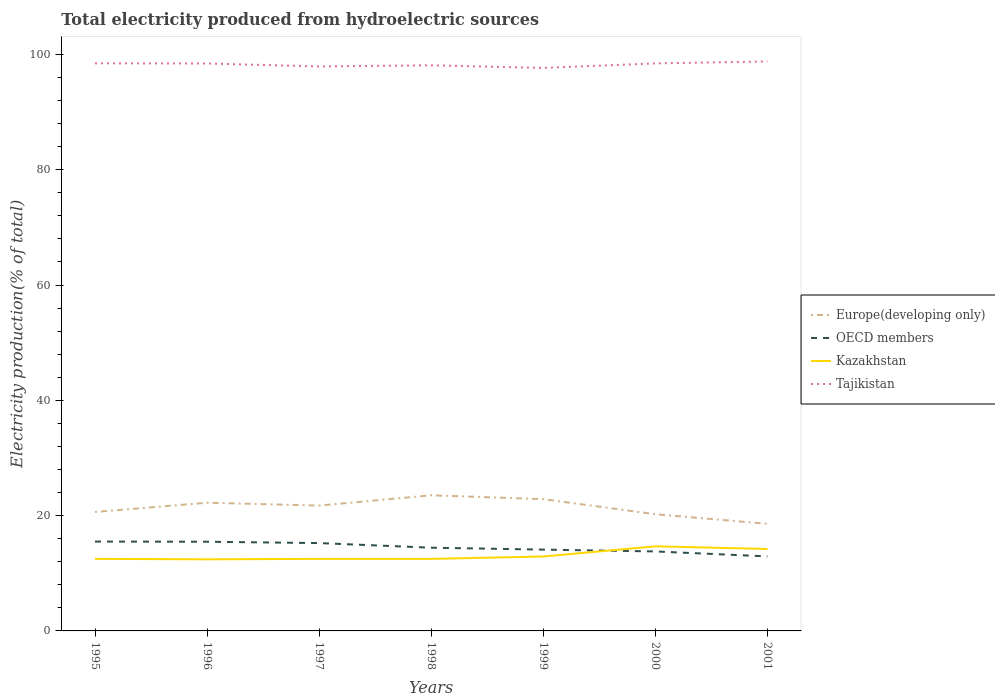Is the number of lines equal to the number of legend labels?
Keep it short and to the point. Yes. Across all years, what is the maximum total electricity produced in Europe(developing only)?
Your answer should be compact. 18.58. What is the total total electricity produced in Tajikistan in the graph?
Make the answer very short. -0.53. What is the difference between the highest and the second highest total electricity produced in Europe(developing only)?
Your response must be concise. 4.95. How many lines are there?
Offer a terse response. 4. Are the values on the major ticks of Y-axis written in scientific E-notation?
Offer a terse response. No. Does the graph contain grids?
Give a very brief answer. No. What is the title of the graph?
Ensure brevity in your answer.  Total electricity produced from hydroelectric sources. What is the label or title of the X-axis?
Ensure brevity in your answer.  Years. What is the Electricity production(% of total) in Europe(developing only) in 1995?
Provide a succinct answer. 20.63. What is the Electricity production(% of total) in OECD members in 1995?
Offer a very short reply. 15.5. What is the Electricity production(% of total) in Kazakhstan in 1995?
Provide a short and direct response. 12.5. What is the Electricity production(% of total) in Tajikistan in 1995?
Keep it short and to the point. 98.46. What is the Electricity production(% of total) of Europe(developing only) in 1996?
Ensure brevity in your answer.  22.24. What is the Electricity production(% of total) in OECD members in 1996?
Your response must be concise. 15.47. What is the Electricity production(% of total) of Kazakhstan in 1996?
Your response must be concise. 12.42. What is the Electricity production(% of total) of Tajikistan in 1996?
Offer a terse response. 98.43. What is the Electricity production(% of total) of Europe(developing only) in 1997?
Provide a short and direct response. 21.74. What is the Electricity production(% of total) of OECD members in 1997?
Provide a succinct answer. 15.24. What is the Electricity production(% of total) of Kazakhstan in 1997?
Your answer should be very brief. 12.5. What is the Electricity production(% of total) of Tajikistan in 1997?
Provide a succinct answer. 97.92. What is the Electricity production(% of total) of Europe(developing only) in 1998?
Give a very brief answer. 23.53. What is the Electricity production(% of total) of OECD members in 1998?
Your answer should be compact. 14.44. What is the Electricity production(% of total) of Kazakhstan in 1998?
Your answer should be very brief. 12.5. What is the Electricity production(% of total) of Tajikistan in 1998?
Provide a short and direct response. 98.11. What is the Electricity production(% of total) of Europe(developing only) in 1999?
Give a very brief answer. 22.86. What is the Electricity production(% of total) of OECD members in 1999?
Make the answer very short. 14.1. What is the Electricity production(% of total) of Kazakhstan in 1999?
Ensure brevity in your answer.  12.91. What is the Electricity production(% of total) of Tajikistan in 1999?
Make the answer very short. 97.66. What is the Electricity production(% of total) in Europe(developing only) in 2000?
Ensure brevity in your answer.  20.24. What is the Electricity production(% of total) in OECD members in 2000?
Offer a terse response. 13.79. What is the Electricity production(% of total) in Kazakhstan in 2000?
Keep it short and to the point. 14.67. What is the Electricity production(% of total) in Tajikistan in 2000?
Offer a terse response. 98.44. What is the Electricity production(% of total) in Europe(developing only) in 2001?
Give a very brief answer. 18.58. What is the Electricity production(% of total) in OECD members in 2001?
Ensure brevity in your answer.  12.92. What is the Electricity production(% of total) of Kazakhstan in 2001?
Your response must be concise. 14.21. What is the Electricity production(% of total) in Tajikistan in 2001?
Your answer should be very brief. 98.78. Across all years, what is the maximum Electricity production(% of total) of Europe(developing only)?
Keep it short and to the point. 23.53. Across all years, what is the maximum Electricity production(% of total) in OECD members?
Your answer should be compact. 15.5. Across all years, what is the maximum Electricity production(% of total) in Kazakhstan?
Make the answer very short. 14.67. Across all years, what is the maximum Electricity production(% of total) of Tajikistan?
Ensure brevity in your answer.  98.78. Across all years, what is the minimum Electricity production(% of total) in Europe(developing only)?
Offer a very short reply. 18.58. Across all years, what is the minimum Electricity production(% of total) of OECD members?
Your answer should be very brief. 12.92. Across all years, what is the minimum Electricity production(% of total) in Kazakhstan?
Your answer should be compact. 12.42. Across all years, what is the minimum Electricity production(% of total) in Tajikistan?
Your answer should be compact. 97.66. What is the total Electricity production(% of total) in Europe(developing only) in the graph?
Your response must be concise. 149.82. What is the total Electricity production(% of total) in OECD members in the graph?
Provide a short and direct response. 101.46. What is the total Electricity production(% of total) in Kazakhstan in the graph?
Provide a succinct answer. 91.71. What is the total Electricity production(% of total) of Tajikistan in the graph?
Make the answer very short. 687.78. What is the difference between the Electricity production(% of total) in Europe(developing only) in 1995 and that in 1996?
Provide a succinct answer. -1.6. What is the difference between the Electricity production(% of total) in OECD members in 1995 and that in 1996?
Give a very brief answer. 0.03. What is the difference between the Electricity production(% of total) of Kazakhstan in 1995 and that in 1996?
Offer a very short reply. 0.08. What is the difference between the Electricity production(% of total) of Tajikistan in 1995 and that in 1996?
Your answer should be compact. 0.03. What is the difference between the Electricity production(% of total) in Europe(developing only) in 1995 and that in 1997?
Provide a succinct answer. -1.11. What is the difference between the Electricity production(% of total) in OECD members in 1995 and that in 1997?
Your response must be concise. 0.26. What is the difference between the Electricity production(% of total) of Kazakhstan in 1995 and that in 1997?
Your answer should be compact. -0. What is the difference between the Electricity production(% of total) in Tajikistan in 1995 and that in 1997?
Your answer should be compact. 0.54. What is the difference between the Electricity production(% of total) in Europe(developing only) in 1995 and that in 1998?
Provide a succinct answer. -2.89. What is the difference between the Electricity production(% of total) of OECD members in 1995 and that in 1998?
Offer a terse response. 1.06. What is the difference between the Electricity production(% of total) in Kazakhstan in 1995 and that in 1998?
Ensure brevity in your answer.  0. What is the difference between the Electricity production(% of total) of Tajikistan in 1995 and that in 1998?
Ensure brevity in your answer.  0.35. What is the difference between the Electricity production(% of total) in Europe(developing only) in 1995 and that in 1999?
Your answer should be compact. -2.22. What is the difference between the Electricity production(% of total) in OECD members in 1995 and that in 1999?
Your response must be concise. 1.4. What is the difference between the Electricity production(% of total) in Kazakhstan in 1995 and that in 1999?
Your answer should be very brief. -0.41. What is the difference between the Electricity production(% of total) of Tajikistan in 1995 and that in 1999?
Ensure brevity in your answer.  0.8. What is the difference between the Electricity production(% of total) in Europe(developing only) in 1995 and that in 2000?
Provide a short and direct response. 0.39. What is the difference between the Electricity production(% of total) of OECD members in 1995 and that in 2000?
Give a very brief answer. 1.71. What is the difference between the Electricity production(% of total) in Kazakhstan in 1995 and that in 2000?
Your answer should be compact. -2.18. What is the difference between the Electricity production(% of total) in Tajikistan in 1995 and that in 2000?
Ensure brevity in your answer.  0.01. What is the difference between the Electricity production(% of total) of Europe(developing only) in 1995 and that in 2001?
Give a very brief answer. 2.05. What is the difference between the Electricity production(% of total) of OECD members in 1995 and that in 2001?
Give a very brief answer. 2.58. What is the difference between the Electricity production(% of total) of Kazakhstan in 1995 and that in 2001?
Ensure brevity in your answer.  -1.72. What is the difference between the Electricity production(% of total) of Tajikistan in 1995 and that in 2001?
Give a very brief answer. -0.32. What is the difference between the Electricity production(% of total) in Europe(developing only) in 1996 and that in 1997?
Ensure brevity in your answer.  0.49. What is the difference between the Electricity production(% of total) of OECD members in 1996 and that in 1997?
Keep it short and to the point. 0.24. What is the difference between the Electricity production(% of total) of Kazakhstan in 1996 and that in 1997?
Offer a very short reply. -0.08. What is the difference between the Electricity production(% of total) of Tajikistan in 1996 and that in 1997?
Make the answer very short. 0.51. What is the difference between the Electricity production(% of total) of Europe(developing only) in 1996 and that in 1998?
Your answer should be compact. -1.29. What is the difference between the Electricity production(% of total) in OECD members in 1996 and that in 1998?
Give a very brief answer. 1.04. What is the difference between the Electricity production(% of total) in Kazakhstan in 1996 and that in 1998?
Your answer should be compact. -0.08. What is the difference between the Electricity production(% of total) in Tajikistan in 1996 and that in 1998?
Your response must be concise. 0.32. What is the difference between the Electricity production(% of total) of Europe(developing only) in 1996 and that in 1999?
Ensure brevity in your answer.  -0.62. What is the difference between the Electricity production(% of total) in OECD members in 1996 and that in 1999?
Keep it short and to the point. 1.37. What is the difference between the Electricity production(% of total) in Kazakhstan in 1996 and that in 1999?
Keep it short and to the point. -0.49. What is the difference between the Electricity production(% of total) of Tajikistan in 1996 and that in 1999?
Your answer should be very brief. 0.77. What is the difference between the Electricity production(% of total) of Europe(developing only) in 1996 and that in 2000?
Offer a very short reply. 2. What is the difference between the Electricity production(% of total) of OECD members in 1996 and that in 2000?
Provide a short and direct response. 1.68. What is the difference between the Electricity production(% of total) of Kazakhstan in 1996 and that in 2000?
Offer a very short reply. -2.26. What is the difference between the Electricity production(% of total) in Tajikistan in 1996 and that in 2000?
Your answer should be compact. -0.02. What is the difference between the Electricity production(% of total) of Europe(developing only) in 1996 and that in 2001?
Offer a very short reply. 3.66. What is the difference between the Electricity production(% of total) of OECD members in 1996 and that in 2001?
Provide a short and direct response. 2.55. What is the difference between the Electricity production(% of total) in Kazakhstan in 1996 and that in 2001?
Your response must be concise. -1.8. What is the difference between the Electricity production(% of total) in Tajikistan in 1996 and that in 2001?
Make the answer very short. -0.35. What is the difference between the Electricity production(% of total) in Europe(developing only) in 1997 and that in 1998?
Keep it short and to the point. -1.78. What is the difference between the Electricity production(% of total) of OECD members in 1997 and that in 1998?
Ensure brevity in your answer.  0.8. What is the difference between the Electricity production(% of total) in Kazakhstan in 1997 and that in 1998?
Ensure brevity in your answer.  0. What is the difference between the Electricity production(% of total) of Tajikistan in 1997 and that in 1998?
Ensure brevity in your answer.  -0.19. What is the difference between the Electricity production(% of total) of Europe(developing only) in 1997 and that in 1999?
Offer a terse response. -1.11. What is the difference between the Electricity production(% of total) of OECD members in 1997 and that in 1999?
Give a very brief answer. 1.13. What is the difference between the Electricity production(% of total) in Kazakhstan in 1997 and that in 1999?
Offer a very short reply. -0.41. What is the difference between the Electricity production(% of total) in Tajikistan in 1997 and that in 1999?
Give a very brief answer. 0.26. What is the difference between the Electricity production(% of total) in Europe(developing only) in 1997 and that in 2000?
Make the answer very short. 1.5. What is the difference between the Electricity production(% of total) of OECD members in 1997 and that in 2000?
Your answer should be very brief. 1.45. What is the difference between the Electricity production(% of total) in Kazakhstan in 1997 and that in 2000?
Offer a very short reply. -2.18. What is the difference between the Electricity production(% of total) in Tajikistan in 1997 and that in 2000?
Offer a terse response. -0.53. What is the difference between the Electricity production(% of total) of Europe(developing only) in 1997 and that in 2001?
Provide a short and direct response. 3.16. What is the difference between the Electricity production(% of total) of OECD members in 1997 and that in 2001?
Keep it short and to the point. 2.31. What is the difference between the Electricity production(% of total) of Kazakhstan in 1997 and that in 2001?
Your answer should be very brief. -1.71. What is the difference between the Electricity production(% of total) of Tajikistan in 1997 and that in 2001?
Provide a short and direct response. -0.86. What is the difference between the Electricity production(% of total) of Europe(developing only) in 1998 and that in 1999?
Keep it short and to the point. 0.67. What is the difference between the Electricity production(% of total) in OECD members in 1998 and that in 1999?
Offer a very short reply. 0.33. What is the difference between the Electricity production(% of total) of Kazakhstan in 1998 and that in 1999?
Give a very brief answer. -0.41. What is the difference between the Electricity production(% of total) of Tajikistan in 1998 and that in 1999?
Keep it short and to the point. 0.45. What is the difference between the Electricity production(% of total) of Europe(developing only) in 1998 and that in 2000?
Keep it short and to the point. 3.29. What is the difference between the Electricity production(% of total) of OECD members in 1998 and that in 2000?
Offer a very short reply. 0.65. What is the difference between the Electricity production(% of total) in Kazakhstan in 1998 and that in 2000?
Ensure brevity in your answer.  -2.18. What is the difference between the Electricity production(% of total) in Tajikistan in 1998 and that in 2000?
Offer a terse response. -0.33. What is the difference between the Electricity production(% of total) in Europe(developing only) in 1998 and that in 2001?
Ensure brevity in your answer.  4.95. What is the difference between the Electricity production(% of total) in OECD members in 1998 and that in 2001?
Your response must be concise. 1.51. What is the difference between the Electricity production(% of total) in Kazakhstan in 1998 and that in 2001?
Your answer should be very brief. -1.72. What is the difference between the Electricity production(% of total) of Tajikistan in 1998 and that in 2001?
Make the answer very short. -0.67. What is the difference between the Electricity production(% of total) in Europe(developing only) in 1999 and that in 2000?
Your answer should be compact. 2.61. What is the difference between the Electricity production(% of total) of OECD members in 1999 and that in 2000?
Provide a succinct answer. 0.32. What is the difference between the Electricity production(% of total) in Kazakhstan in 1999 and that in 2000?
Provide a succinct answer. -1.76. What is the difference between the Electricity production(% of total) of Tajikistan in 1999 and that in 2000?
Give a very brief answer. -0.78. What is the difference between the Electricity production(% of total) in Europe(developing only) in 1999 and that in 2001?
Keep it short and to the point. 4.27. What is the difference between the Electricity production(% of total) of OECD members in 1999 and that in 2001?
Offer a very short reply. 1.18. What is the difference between the Electricity production(% of total) in Kazakhstan in 1999 and that in 2001?
Ensure brevity in your answer.  -1.3. What is the difference between the Electricity production(% of total) in Tajikistan in 1999 and that in 2001?
Your answer should be very brief. -1.12. What is the difference between the Electricity production(% of total) in Europe(developing only) in 2000 and that in 2001?
Provide a short and direct response. 1.66. What is the difference between the Electricity production(% of total) of OECD members in 2000 and that in 2001?
Make the answer very short. 0.86. What is the difference between the Electricity production(% of total) in Kazakhstan in 2000 and that in 2001?
Your answer should be very brief. 0.46. What is the difference between the Electricity production(% of total) in Tajikistan in 2000 and that in 2001?
Make the answer very short. -0.33. What is the difference between the Electricity production(% of total) of Europe(developing only) in 1995 and the Electricity production(% of total) of OECD members in 1996?
Keep it short and to the point. 5.16. What is the difference between the Electricity production(% of total) in Europe(developing only) in 1995 and the Electricity production(% of total) in Kazakhstan in 1996?
Make the answer very short. 8.22. What is the difference between the Electricity production(% of total) of Europe(developing only) in 1995 and the Electricity production(% of total) of Tajikistan in 1996?
Your answer should be very brief. -77.79. What is the difference between the Electricity production(% of total) of OECD members in 1995 and the Electricity production(% of total) of Kazakhstan in 1996?
Your response must be concise. 3.08. What is the difference between the Electricity production(% of total) of OECD members in 1995 and the Electricity production(% of total) of Tajikistan in 1996?
Offer a terse response. -82.93. What is the difference between the Electricity production(% of total) in Kazakhstan in 1995 and the Electricity production(% of total) in Tajikistan in 1996?
Provide a succinct answer. -85.93. What is the difference between the Electricity production(% of total) of Europe(developing only) in 1995 and the Electricity production(% of total) of OECD members in 1997?
Your response must be concise. 5.4. What is the difference between the Electricity production(% of total) of Europe(developing only) in 1995 and the Electricity production(% of total) of Kazakhstan in 1997?
Offer a terse response. 8.14. What is the difference between the Electricity production(% of total) of Europe(developing only) in 1995 and the Electricity production(% of total) of Tajikistan in 1997?
Keep it short and to the point. -77.28. What is the difference between the Electricity production(% of total) of OECD members in 1995 and the Electricity production(% of total) of Kazakhstan in 1997?
Give a very brief answer. 3. What is the difference between the Electricity production(% of total) of OECD members in 1995 and the Electricity production(% of total) of Tajikistan in 1997?
Give a very brief answer. -82.42. What is the difference between the Electricity production(% of total) of Kazakhstan in 1995 and the Electricity production(% of total) of Tajikistan in 1997?
Ensure brevity in your answer.  -85.42. What is the difference between the Electricity production(% of total) of Europe(developing only) in 1995 and the Electricity production(% of total) of OECD members in 1998?
Make the answer very short. 6.2. What is the difference between the Electricity production(% of total) of Europe(developing only) in 1995 and the Electricity production(% of total) of Kazakhstan in 1998?
Your answer should be very brief. 8.14. What is the difference between the Electricity production(% of total) of Europe(developing only) in 1995 and the Electricity production(% of total) of Tajikistan in 1998?
Your answer should be very brief. -77.47. What is the difference between the Electricity production(% of total) in OECD members in 1995 and the Electricity production(% of total) in Kazakhstan in 1998?
Your response must be concise. 3. What is the difference between the Electricity production(% of total) of OECD members in 1995 and the Electricity production(% of total) of Tajikistan in 1998?
Keep it short and to the point. -82.61. What is the difference between the Electricity production(% of total) in Kazakhstan in 1995 and the Electricity production(% of total) in Tajikistan in 1998?
Provide a short and direct response. -85.61. What is the difference between the Electricity production(% of total) in Europe(developing only) in 1995 and the Electricity production(% of total) in OECD members in 1999?
Your response must be concise. 6.53. What is the difference between the Electricity production(% of total) of Europe(developing only) in 1995 and the Electricity production(% of total) of Kazakhstan in 1999?
Keep it short and to the point. 7.72. What is the difference between the Electricity production(% of total) in Europe(developing only) in 1995 and the Electricity production(% of total) in Tajikistan in 1999?
Provide a short and direct response. -77.02. What is the difference between the Electricity production(% of total) of OECD members in 1995 and the Electricity production(% of total) of Kazakhstan in 1999?
Your answer should be very brief. 2.59. What is the difference between the Electricity production(% of total) in OECD members in 1995 and the Electricity production(% of total) in Tajikistan in 1999?
Provide a succinct answer. -82.16. What is the difference between the Electricity production(% of total) in Kazakhstan in 1995 and the Electricity production(% of total) in Tajikistan in 1999?
Your answer should be very brief. -85.16. What is the difference between the Electricity production(% of total) in Europe(developing only) in 1995 and the Electricity production(% of total) in OECD members in 2000?
Offer a very short reply. 6.85. What is the difference between the Electricity production(% of total) of Europe(developing only) in 1995 and the Electricity production(% of total) of Kazakhstan in 2000?
Offer a terse response. 5.96. What is the difference between the Electricity production(% of total) of Europe(developing only) in 1995 and the Electricity production(% of total) of Tajikistan in 2000?
Give a very brief answer. -77.81. What is the difference between the Electricity production(% of total) in OECD members in 1995 and the Electricity production(% of total) in Kazakhstan in 2000?
Offer a very short reply. 0.83. What is the difference between the Electricity production(% of total) in OECD members in 1995 and the Electricity production(% of total) in Tajikistan in 2000?
Offer a very short reply. -82.94. What is the difference between the Electricity production(% of total) in Kazakhstan in 1995 and the Electricity production(% of total) in Tajikistan in 2000?
Offer a very short reply. -85.94. What is the difference between the Electricity production(% of total) in Europe(developing only) in 1995 and the Electricity production(% of total) in OECD members in 2001?
Your answer should be compact. 7.71. What is the difference between the Electricity production(% of total) in Europe(developing only) in 1995 and the Electricity production(% of total) in Kazakhstan in 2001?
Offer a very short reply. 6.42. What is the difference between the Electricity production(% of total) of Europe(developing only) in 1995 and the Electricity production(% of total) of Tajikistan in 2001?
Provide a succinct answer. -78.14. What is the difference between the Electricity production(% of total) in OECD members in 1995 and the Electricity production(% of total) in Kazakhstan in 2001?
Your answer should be compact. 1.29. What is the difference between the Electricity production(% of total) of OECD members in 1995 and the Electricity production(% of total) of Tajikistan in 2001?
Your response must be concise. -83.28. What is the difference between the Electricity production(% of total) in Kazakhstan in 1995 and the Electricity production(% of total) in Tajikistan in 2001?
Your response must be concise. -86.28. What is the difference between the Electricity production(% of total) in Europe(developing only) in 1996 and the Electricity production(% of total) in OECD members in 1997?
Offer a very short reply. 7. What is the difference between the Electricity production(% of total) in Europe(developing only) in 1996 and the Electricity production(% of total) in Kazakhstan in 1997?
Offer a very short reply. 9.74. What is the difference between the Electricity production(% of total) in Europe(developing only) in 1996 and the Electricity production(% of total) in Tajikistan in 1997?
Provide a succinct answer. -75.68. What is the difference between the Electricity production(% of total) of OECD members in 1996 and the Electricity production(% of total) of Kazakhstan in 1997?
Give a very brief answer. 2.97. What is the difference between the Electricity production(% of total) in OECD members in 1996 and the Electricity production(% of total) in Tajikistan in 1997?
Give a very brief answer. -82.44. What is the difference between the Electricity production(% of total) of Kazakhstan in 1996 and the Electricity production(% of total) of Tajikistan in 1997?
Give a very brief answer. -85.5. What is the difference between the Electricity production(% of total) of Europe(developing only) in 1996 and the Electricity production(% of total) of OECD members in 1998?
Offer a very short reply. 7.8. What is the difference between the Electricity production(% of total) of Europe(developing only) in 1996 and the Electricity production(% of total) of Kazakhstan in 1998?
Your response must be concise. 9.74. What is the difference between the Electricity production(% of total) of Europe(developing only) in 1996 and the Electricity production(% of total) of Tajikistan in 1998?
Provide a short and direct response. -75.87. What is the difference between the Electricity production(% of total) in OECD members in 1996 and the Electricity production(% of total) in Kazakhstan in 1998?
Your response must be concise. 2.98. What is the difference between the Electricity production(% of total) of OECD members in 1996 and the Electricity production(% of total) of Tajikistan in 1998?
Make the answer very short. -82.64. What is the difference between the Electricity production(% of total) of Kazakhstan in 1996 and the Electricity production(% of total) of Tajikistan in 1998?
Your answer should be compact. -85.69. What is the difference between the Electricity production(% of total) of Europe(developing only) in 1996 and the Electricity production(% of total) of OECD members in 1999?
Keep it short and to the point. 8.13. What is the difference between the Electricity production(% of total) of Europe(developing only) in 1996 and the Electricity production(% of total) of Kazakhstan in 1999?
Your answer should be compact. 9.33. What is the difference between the Electricity production(% of total) in Europe(developing only) in 1996 and the Electricity production(% of total) in Tajikistan in 1999?
Your answer should be compact. -75.42. What is the difference between the Electricity production(% of total) in OECD members in 1996 and the Electricity production(% of total) in Kazakhstan in 1999?
Keep it short and to the point. 2.56. What is the difference between the Electricity production(% of total) of OECD members in 1996 and the Electricity production(% of total) of Tajikistan in 1999?
Your answer should be very brief. -82.19. What is the difference between the Electricity production(% of total) of Kazakhstan in 1996 and the Electricity production(% of total) of Tajikistan in 1999?
Your answer should be very brief. -85.24. What is the difference between the Electricity production(% of total) in Europe(developing only) in 1996 and the Electricity production(% of total) in OECD members in 2000?
Offer a very short reply. 8.45. What is the difference between the Electricity production(% of total) in Europe(developing only) in 1996 and the Electricity production(% of total) in Kazakhstan in 2000?
Provide a succinct answer. 7.56. What is the difference between the Electricity production(% of total) of Europe(developing only) in 1996 and the Electricity production(% of total) of Tajikistan in 2000?
Offer a very short reply. -76.21. What is the difference between the Electricity production(% of total) in OECD members in 1996 and the Electricity production(% of total) in Kazakhstan in 2000?
Make the answer very short. 0.8. What is the difference between the Electricity production(% of total) in OECD members in 1996 and the Electricity production(% of total) in Tajikistan in 2000?
Offer a very short reply. -82.97. What is the difference between the Electricity production(% of total) in Kazakhstan in 1996 and the Electricity production(% of total) in Tajikistan in 2000?
Offer a very short reply. -86.02. What is the difference between the Electricity production(% of total) of Europe(developing only) in 1996 and the Electricity production(% of total) of OECD members in 2001?
Your answer should be very brief. 9.31. What is the difference between the Electricity production(% of total) of Europe(developing only) in 1996 and the Electricity production(% of total) of Kazakhstan in 2001?
Keep it short and to the point. 8.02. What is the difference between the Electricity production(% of total) in Europe(developing only) in 1996 and the Electricity production(% of total) in Tajikistan in 2001?
Provide a succinct answer. -76.54. What is the difference between the Electricity production(% of total) of OECD members in 1996 and the Electricity production(% of total) of Kazakhstan in 2001?
Ensure brevity in your answer.  1.26. What is the difference between the Electricity production(% of total) of OECD members in 1996 and the Electricity production(% of total) of Tajikistan in 2001?
Make the answer very short. -83.31. What is the difference between the Electricity production(% of total) in Kazakhstan in 1996 and the Electricity production(% of total) in Tajikistan in 2001?
Provide a short and direct response. -86.36. What is the difference between the Electricity production(% of total) in Europe(developing only) in 1997 and the Electricity production(% of total) in OECD members in 1998?
Provide a short and direct response. 7.31. What is the difference between the Electricity production(% of total) of Europe(developing only) in 1997 and the Electricity production(% of total) of Kazakhstan in 1998?
Your answer should be very brief. 9.25. What is the difference between the Electricity production(% of total) of Europe(developing only) in 1997 and the Electricity production(% of total) of Tajikistan in 1998?
Give a very brief answer. -76.36. What is the difference between the Electricity production(% of total) in OECD members in 1997 and the Electricity production(% of total) in Kazakhstan in 1998?
Your answer should be compact. 2.74. What is the difference between the Electricity production(% of total) in OECD members in 1997 and the Electricity production(% of total) in Tajikistan in 1998?
Ensure brevity in your answer.  -82.87. What is the difference between the Electricity production(% of total) in Kazakhstan in 1997 and the Electricity production(% of total) in Tajikistan in 1998?
Your answer should be very brief. -85.61. What is the difference between the Electricity production(% of total) of Europe(developing only) in 1997 and the Electricity production(% of total) of OECD members in 1999?
Your answer should be very brief. 7.64. What is the difference between the Electricity production(% of total) of Europe(developing only) in 1997 and the Electricity production(% of total) of Kazakhstan in 1999?
Give a very brief answer. 8.83. What is the difference between the Electricity production(% of total) of Europe(developing only) in 1997 and the Electricity production(% of total) of Tajikistan in 1999?
Offer a terse response. -75.91. What is the difference between the Electricity production(% of total) in OECD members in 1997 and the Electricity production(% of total) in Kazakhstan in 1999?
Offer a terse response. 2.33. What is the difference between the Electricity production(% of total) of OECD members in 1997 and the Electricity production(% of total) of Tajikistan in 1999?
Keep it short and to the point. -82.42. What is the difference between the Electricity production(% of total) of Kazakhstan in 1997 and the Electricity production(% of total) of Tajikistan in 1999?
Make the answer very short. -85.16. What is the difference between the Electricity production(% of total) of Europe(developing only) in 1997 and the Electricity production(% of total) of OECD members in 2000?
Make the answer very short. 7.96. What is the difference between the Electricity production(% of total) of Europe(developing only) in 1997 and the Electricity production(% of total) of Kazakhstan in 2000?
Your answer should be very brief. 7.07. What is the difference between the Electricity production(% of total) of Europe(developing only) in 1997 and the Electricity production(% of total) of Tajikistan in 2000?
Give a very brief answer. -76.7. What is the difference between the Electricity production(% of total) in OECD members in 1997 and the Electricity production(% of total) in Kazakhstan in 2000?
Offer a terse response. 0.56. What is the difference between the Electricity production(% of total) in OECD members in 1997 and the Electricity production(% of total) in Tajikistan in 2000?
Your response must be concise. -83.21. What is the difference between the Electricity production(% of total) of Kazakhstan in 1997 and the Electricity production(% of total) of Tajikistan in 2000?
Provide a short and direct response. -85.94. What is the difference between the Electricity production(% of total) of Europe(developing only) in 1997 and the Electricity production(% of total) of OECD members in 2001?
Provide a succinct answer. 8.82. What is the difference between the Electricity production(% of total) of Europe(developing only) in 1997 and the Electricity production(% of total) of Kazakhstan in 2001?
Provide a succinct answer. 7.53. What is the difference between the Electricity production(% of total) of Europe(developing only) in 1997 and the Electricity production(% of total) of Tajikistan in 2001?
Your response must be concise. -77.03. What is the difference between the Electricity production(% of total) of OECD members in 1997 and the Electricity production(% of total) of Kazakhstan in 2001?
Your response must be concise. 1.02. What is the difference between the Electricity production(% of total) in OECD members in 1997 and the Electricity production(% of total) in Tajikistan in 2001?
Keep it short and to the point. -83.54. What is the difference between the Electricity production(% of total) in Kazakhstan in 1997 and the Electricity production(% of total) in Tajikistan in 2001?
Make the answer very short. -86.28. What is the difference between the Electricity production(% of total) in Europe(developing only) in 1998 and the Electricity production(% of total) in OECD members in 1999?
Give a very brief answer. 9.42. What is the difference between the Electricity production(% of total) in Europe(developing only) in 1998 and the Electricity production(% of total) in Kazakhstan in 1999?
Your answer should be very brief. 10.62. What is the difference between the Electricity production(% of total) in Europe(developing only) in 1998 and the Electricity production(% of total) in Tajikistan in 1999?
Offer a terse response. -74.13. What is the difference between the Electricity production(% of total) of OECD members in 1998 and the Electricity production(% of total) of Kazakhstan in 1999?
Ensure brevity in your answer.  1.53. What is the difference between the Electricity production(% of total) in OECD members in 1998 and the Electricity production(% of total) in Tajikistan in 1999?
Your answer should be very brief. -83.22. What is the difference between the Electricity production(% of total) in Kazakhstan in 1998 and the Electricity production(% of total) in Tajikistan in 1999?
Provide a succinct answer. -85.16. What is the difference between the Electricity production(% of total) in Europe(developing only) in 1998 and the Electricity production(% of total) in OECD members in 2000?
Provide a succinct answer. 9.74. What is the difference between the Electricity production(% of total) in Europe(developing only) in 1998 and the Electricity production(% of total) in Kazakhstan in 2000?
Offer a terse response. 8.85. What is the difference between the Electricity production(% of total) of Europe(developing only) in 1998 and the Electricity production(% of total) of Tajikistan in 2000?
Keep it short and to the point. -74.91. What is the difference between the Electricity production(% of total) in OECD members in 1998 and the Electricity production(% of total) in Kazakhstan in 2000?
Your response must be concise. -0.24. What is the difference between the Electricity production(% of total) of OECD members in 1998 and the Electricity production(% of total) of Tajikistan in 2000?
Provide a short and direct response. -84.01. What is the difference between the Electricity production(% of total) in Kazakhstan in 1998 and the Electricity production(% of total) in Tajikistan in 2000?
Offer a terse response. -85.95. What is the difference between the Electricity production(% of total) of Europe(developing only) in 1998 and the Electricity production(% of total) of OECD members in 2001?
Provide a succinct answer. 10.6. What is the difference between the Electricity production(% of total) of Europe(developing only) in 1998 and the Electricity production(% of total) of Kazakhstan in 2001?
Give a very brief answer. 9.32. What is the difference between the Electricity production(% of total) of Europe(developing only) in 1998 and the Electricity production(% of total) of Tajikistan in 2001?
Keep it short and to the point. -75.25. What is the difference between the Electricity production(% of total) in OECD members in 1998 and the Electricity production(% of total) in Kazakhstan in 2001?
Your answer should be compact. 0.22. What is the difference between the Electricity production(% of total) in OECD members in 1998 and the Electricity production(% of total) in Tajikistan in 2001?
Keep it short and to the point. -84.34. What is the difference between the Electricity production(% of total) of Kazakhstan in 1998 and the Electricity production(% of total) of Tajikistan in 2001?
Your response must be concise. -86.28. What is the difference between the Electricity production(% of total) of Europe(developing only) in 1999 and the Electricity production(% of total) of OECD members in 2000?
Offer a very short reply. 9.07. What is the difference between the Electricity production(% of total) of Europe(developing only) in 1999 and the Electricity production(% of total) of Kazakhstan in 2000?
Your answer should be very brief. 8.18. What is the difference between the Electricity production(% of total) in Europe(developing only) in 1999 and the Electricity production(% of total) in Tajikistan in 2000?
Make the answer very short. -75.59. What is the difference between the Electricity production(% of total) of OECD members in 1999 and the Electricity production(% of total) of Kazakhstan in 2000?
Provide a short and direct response. -0.57. What is the difference between the Electricity production(% of total) of OECD members in 1999 and the Electricity production(% of total) of Tajikistan in 2000?
Offer a terse response. -84.34. What is the difference between the Electricity production(% of total) of Kazakhstan in 1999 and the Electricity production(% of total) of Tajikistan in 2000?
Offer a very short reply. -85.53. What is the difference between the Electricity production(% of total) of Europe(developing only) in 1999 and the Electricity production(% of total) of OECD members in 2001?
Offer a very short reply. 9.93. What is the difference between the Electricity production(% of total) of Europe(developing only) in 1999 and the Electricity production(% of total) of Kazakhstan in 2001?
Your response must be concise. 8.64. What is the difference between the Electricity production(% of total) of Europe(developing only) in 1999 and the Electricity production(% of total) of Tajikistan in 2001?
Provide a succinct answer. -75.92. What is the difference between the Electricity production(% of total) of OECD members in 1999 and the Electricity production(% of total) of Kazakhstan in 2001?
Give a very brief answer. -0.11. What is the difference between the Electricity production(% of total) of OECD members in 1999 and the Electricity production(% of total) of Tajikistan in 2001?
Offer a very short reply. -84.67. What is the difference between the Electricity production(% of total) of Kazakhstan in 1999 and the Electricity production(% of total) of Tajikistan in 2001?
Offer a terse response. -85.87. What is the difference between the Electricity production(% of total) of Europe(developing only) in 2000 and the Electricity production(% of total) of OECD members in 2001?
Ensure brevity in your answer.  7.32. What is the difference between the Electricity production(% of total) in Europe(developing only) in 2000 and the Electricity production(% of total) in Kazakhstan in 2001?
Make the answer very short. 6.03. What is the difference between the Electricity production(% of total) in Europe(developing only) in 2000 and the Electricity production(% of total) in Tajikistan in 2001?
Keep it short and to the point. -78.54. What is the difference between the Electricity production(% of total) in OECD members in 2000 and the Electricity production(% of total) in Kazakhstan in 2001?
Provide a short and direct response. -0.42. What is the difference between the Electricity production(% of total) of OECD members in 2000 and the Electricity production(% of total) of Tajikistan in 2001?
Your response must be concise. -84.99. What is the difference between the Electricity production(% of total) of Kazakhstan in 2000 and the Electricity production(% of total) of Tajikistan in 2001?
Ensure brevity in your answer.  -84.1. What is the average Electricity production(% of total) in Europe(developing only) per year?
Provide a succinct answer. 21.4. What is the average Electricity production(% of total) of OECD members per year?
Your answer should be compact. 14.49. What is the average Electricity production(% of total) of Kazakhstan per year?
Give a very brief answer. 13.1. What is the average Electricity production(% of total) of Tajikistan per year?
Give a very brief answer. 98.25. In the year 1995, what is the difference between the Electricity production(% of total) of Europe(developing only) and Electricity production(% of total) of OECD members?
Offer a very short reply. 5.13. In the year 1995, what is the difference between the Electricity production(% of total) in Europe(developing only) and Electricity production(% of total) in Kazakhstan?
Offer a terse response. 8.14. In the year 1995, what is the difference between the Electricity production(% of total) in Europe(developing only) and Electricity production(% of total) in Tajikistan?
Provide a short and direct response. -77.82. In the year 1995, what is the difference between the Electricity production(% of total) in OECD members and Electricity production(% of total) in Kazakhstan?
Offer a terse response. 3. In the year 1995, what is the difference between the Electricity production(% of total) in OECD members and Electricity production(% of total) in Tajikistan?
Keep it short and to the point. -82.96. In the year 1995, what is the difference between the Electricity production(% of total) in Kazakhstan and Electricity production(% of total) in Tajikistan?
Make the answer very short. -85.96. In the year 1996, what is the difference between the Electricity production(% of total) in Europe(developing only) and Electricity production(% of total) in OECD members?
Your answer should be very brief. 6.77. In the year 1996, what is the difference between the Electricity production(% of total) in Europe(developing only) and Electricity production(% of total) in Kazakhstan?
Provide a short and direct response. 9.82. In the year 1996, what is the difference between the Electricity production(% of total) of Europe(developing only) and Electricity production(% of total) of Tajikistan?
Ensure brevity in your answer.  -76.19. In the year 1996, what is the difference between the Electricity production(% of total) of OECD members and Electricity production(% of total) of Kazakhstan?
Ensure brevity in your answer.  3.05. In the year 1996, what is the difference between the Electricity production(% of total) in OECD members and Electricity production(% of total) in Tajikistan?
Give a very brief answer. -82.96. In the year 1996, what is the difference between the Electricity production(% of total) of Kazakhstan and Electricity production(% of total) of Tajikistan?
Keep it short and to the point. -86.01. In the year 1997, what is the difference between the Electricity production(% of total) in Europe(developing only) and Electricity production(% of total) in OECD members?
Your response must be concise. 6.51. In the year 1997, what is the difference between the Electricity production(% of total) of Europe(developing only) and Electricity production(% of total) of Kazakhstan?
Offer a terse response. 9.25. In the year 1997, what is the difference between the Electricity production(% of total) in Europe(developing only) and Electricity production(% of total) in Tajikistan?
Make the answer very short. -76.17. In the year 1997, what is the difference between the Electricity production(% of total) of OECD members and Electricity production(% of total) of Kazakhstan?
Your answer should be compact. 2.74. In the year 1997, what is the difference between the Electricity production(% of total) of OECD members and Electricity production(% of total) of Tajikistan?
Provide a succinct answer. -82.68. In the year 1997, what is the difference between the Electricity production(% of total) in Kazakhstan and Electricity production(% of total) in Tajikistan?
Your response must be concise. -85.42. In the year 1998, what is the difference between the Electricity production(% of total) of Europe(developing only) and Electricity production(% of total) of OECD members?
Offer a very short reply. 9.09. In the year 1998, what is the difference between the Electricity production(% of total) of Europe(developing only) and Electricity production(% of total) of Kazakhstan?
Provide a short and direct response. 11.03. In the year 1998, what is the difference between the Electricity production(% of total) of Europe(developing only) and Electricity production(% of total) of Tajikistan?
Provide a succinct answer. -74.58. In the year 1998, what is the difference between the Electricity production(% of total) in OECD members and Electricity production(% of total) in Kazakhstan?
Provide a succinct answer. 1.94. In the year 1998, what is the difference between the Electricity production(% of total) in OECD members and Electricity production(% of total) in Tajikistan?
Provide a short and direct response. -83.67. In the year 1998, what is the difference between the Electricity production(% of total) of Kazakhstan and Electricity production(% of total) of Tajikistan?
Provide a succinct answer. -85.61. In the year 1999, what is the difference between the Electricity production(% of total) in Europe(developing only) and Electricity production(% of total) in OECD members?
Offer a very short reply. 8.75. In the year 1999, what is the difference between the Electricity production(% of total) in Europe(developing only) and Electricity production(% of total) in Kazakhstan?
Your answer should be very brief. 9.95. In the year 1999, what is the difference between the Electricity production(% of total) in Europe(developing only) and Electricity production(% of total) in Tajikistan?
Make the answer very short. -74.8. In the year 1999, what is the difference between the Electricity production(% of total) of OECD members and Electricity production(% of total) of Kazakhstan?
Offer a very short reply. 1.19. In the year 1999, what is the difference between the Electricity production(% of total) in OECD members and Electricity production(% of total) in Tajikistan?
Keep it short and to the point. -83.55. In the year 1999, what is the difference between the Electricity production(% of total) of Kazakhstan and Electricity production(% of total) of Tajikistan?
Offer a terse response. -84.75. In the year 2000, what is the difference between the Electricity production(% of total) in Europe(developing only) and Electricity production(% of total) in OECD members?
Give a very brief answer. 6.45. In the year 2000, what is the difference between the Electricity production(% of total) in Europe(developing only) and Electricity production(% of total) in Kazakhstan?
Offer a terse response. 5.57. In the year 2000, what is the difference between the Electricity production(% of total) of Europe(developing only) and Electricity production(% of total) of Tajikistan?
Your answer should be compact. -78.2. In the year 2000, what is the difference between the Electricity production(% of total) of OECD members and Electricity production(% of total) of Kazakhstan?
Offer a terse response. -0.89. In the year 2000, what is the difference between the Electricity production(% of total) of OECD members and Electricity production(% of total) of Tajikistan?
Offer a terse response. -84.65. In the year 2000, what is the difference between the Electricity production(% of total) in Kazakhstan and Electricity production(% of total) in Tajikistan?
Make the answer very short. -83.77. In the year 2001, what is the difference between the Electricity production(% of total) in Europe(developing only) and Electricity production(% of total) in OECD members?
Your answer should be compact. 5.66. In the year 2001, what is the difference between the Electricity production(% of total) in Europe(developing only) and Electricity production(% of total) in Kazakhstan?
Your answer should be compact. 4.37. In the year 2001, what is the difference between the Electricity production(% of total) of Europe(developing only) and Electricity production(% of total) of Tajikistan?
Offer a terse response. -80.19. In the year 2001, what is the difference between the Electricity production(% of total) of OECD members and Electricity production(% of total) of Kazakhstan?
Ensure brevity in your answer.  -1.29. In the year 2001, what is the difference between the Electricity production(% of total) of OECD members and Electricity production(% of total) of Tajikistan?
Make the answer very short. -85.85. In the year 2001, what is the difference between the Electricity production(% of total) of Kazakhstan and Electricity production(% of total) of Tajikistan?
Offer a very short reply. -84.56. What is the ratio of the Electricity production(% of total) in Europe(developing only) in 1995 to that in 1996?
Keep it short and to the point. 0.93. What is the ratio of the Electricity production(% of total) of OECD members in 1995 to that in 1996?
Offer a terse response. 1. What is the ratio of the Electricity production(% of total) in Kazakhstan in 1995 to that in 1996?
Ensure brevity in your answer.  1.01. What is the ratio of the Electricity production(% of total) of Tajikistan in 1995 to that in 1996?
Offer a very short reply. 1. What is the ratio of the Electricity production(% of total) in Europe(developing only) in 1995 to that in 1997?
Make the answer very short. 0.95. What is the ratio of the Electricity production(% of total) of OECD members in 1995 to that in 1997?
Ensure brevity in your answer.  1.02. What is the ratio of the Electricity production(% of total) of Europe(developing only) in 1995 to that in 1998?
Offer a very short reply. 0.88. What is the ratio of the Electricity production(% of total) in OECD members in 1995 to that in 1998?
Your answer should be very brief. 1.07. What is the ratio of the Electricity production(% of total) of Tajikistan in 1995 to that in 1998?
Provide a succinct answer. 1. What is the ratio of the Electricity production(% of total) of Europe(developing only) in 1995 to that in 1999?
Your answer should be compact. 0.9. What is the ratio of the Electricity production(% of total) of OECD members in 1995 to that in 1999?
Offer a terse response. 1.1. What is the ratio of the Electricity production(% of total) in Kazakhstan in 1995 to that in 1999?
Offer a very short reply. 0.97. What is the ratio of the Electricity production(% of total) in Tajikistan in 1995 to that in 1999?
Provide a short and direct response. 1.01. What is the ratio of the Electricity production(% of total) of Europe(developing only) in 1995 to that in 2000?
Keep it short and to the point. 1.02. What is the ratio of the Electricity production(% of total) in OECD members in 1995 to that in 2000?
Provide a succinct answer. 1.12. What is the ratio of the Electricity production(% of total) in Kazakhstan in 1995 to that in 2000?
Your response must be concise. 0.85. What is the ratio of the Electricity production(% of total) of Tajikistan in 1995 to that in 2000?
Ensure brevity in your answer.  1. What is the ratio of the Electricity production(% of total) of Europe(developing only) in 1995 to that in 2001?
Provide a short and direct response. 1.11. What is the ratio of the Electricity production(% of total) in OECD members in 1995 to that in 2001?
Ensure brevity in your answer.  1.2. What is the ratio of the Electricity production(% of total) in Kazakhstan in 1995 to that in 2001?
Your answer should be very brief. 0.88. What is the ratio of the Electricity production(% of total) in Europe(developing only) in 1996 to that in 1997?
Give a very brief answer. 1.02. What is the ratio of the Electricity production(% of total) of OECD members in 1996 to that in 1997?
Provide a succinct answer. 1.02. What is the ratio of the Electricity production(% of total) in Tajikistan in 1996 to that in 1997?
Offer a very short reply. 1.01. What is the ratio of the Electricity production(% of total) in Europe(developing only) in 1996 to that in 1998?
Offer a terse response. 0.95. What is the ratio of the Electricity production(% of total) in OECD members in 1996 to that in 1998?
Keep it short and to the point. 1.07. What is the ratio of the Electricity production(% of total) of Tajikistan in 1996 to that in 1998?
Provide a succinct answer. 1. What is the ratio of the Electricity production(% of total) in Europe(developing only) in 1996 to that in 1999?
Your answer should be compact. 0.97. What is the ratio of the Electricity production(% of total) of OECD members in 1996 to that in 1999?
Make the answer very short. 1.1. What is the ratio of the Electricity production(% of total) of Kazakhstan in 1996 to that in 1999?
Give a very brief answer. 0.96. What is the ratio of the Electricity production(% of total) in Tajikistan in 1996 to that in 1999?
Provide a succinct answer. 1.01. What is the ratio of the Electricity production(% of total) of Europe(developing only) in 1996 to that in 2000?
Make the answer very short. 1.1. What is the ratio of the Electricity production(% of total) in OECD members in 1996 to that in 2000?
Offer a terse response. 1.12. What is the ratio of the Electricity production(% of total) in Kazakhstan in 1996 to that in 2000?
Ensure brevity in your answer.  0.85. What is the ratio of the Electricity production(% of total) of Tajikistan in 1996 to that in 2000?
Ensure brevity in your answer.  1. What is the ratio of the Electricity production(% of total) in Europe(developing only) in 1996 to that in 2001?
Your answer should be very brief. 1.2. What is the ratio of the Electricity production(% of total) in OECD members in 1996 to that in 2001?
Offer a terse response. 1.2. What is the ratio of the Electricity production(% of total) of Kazakhstan in 1996 to that in 2001?
Provide a short and direct response. 0.87. What is the ratio of the Electricity production(% of total) in Tajikistan in 1996 to that in 2001?
Ensure brevity in your answer.  1. What is the ratio of the Electricity production(% of total) in Europe(developing only) in 1997 to that in 1998?
Make the answer very short. 0.92. What is the ratio of the Electricity production(% of total) of OECD members in 1997 to that in 1998?
Your answer should be very brief. 1.06. What is the ratio of the Electricity production(% of total) of Kazakhstan in 1997 to that in 1998?
Give a very brief answer. 1. What is the ratio of the Electricity production(% of total) in Tajikistan in 1997 to that in 1998?
Provide a short and direct response. 1. What is the ratio of the Electricity production(% of total) in Europe(developing only) in 1997 to that in 1999?
Make the answer very short. 0.95. What is the ratio of the Electricity production(% of total) of OECD members in 1997 to that in 1999?
Ensure brevity in your answer.  1.08. What is the ratio of the Electricity production(% of total) in Kazakhstan in 1997 to that in 1999?
Your answer should be very brief. 0.97. What is the ratio of the Electricity production(% of total) in Tajikistan in 1997 to that in 1999?
Ensure brevity in your answer.  1. What is the ratio of the Electricity production(% of total) in Europe(developing only) in 1997 to that in 2000?
Provide a short and direct response. 1.07. What is the ratio of the Electricity production(% of total) in OECD members in 1997 to that in 2000?
Your answer should be very brief. 1.1. What is the ratio of the Electricity production(% of total) of Kazakhstan in 1997 to that in 2000?
Give a very brief answer. 0.85. What is the ratio of the Electricity production(% of total) in Tajikistan in 1997 to that in 2000?
Ensure brevity in your answer.  0.99. What is the ratio of the Electricity production(% of total) in Europe(developing only) in 1997 to that in 2001?
Your answer should be very brief. 1.17. What is the ratio of the Electricity production(% of total) of OECD members in 1997 to that in 2001?
Offer a very short reply. 1.18. What is the ratio of the Electricity production(% of total) in Kazakhstan in 1997 to that in 2001?
Provide a succinct answer. 0.88. What is the ratio of the Electricity production(% of total) of Tajikistan in 1997 to that in 2001?
Your response must be concise. 0.99. What is the ratio of the Electricity production(% of total) of Europe(developing only) in 1998 to that in 1999?
Offer a terse response. 1.03. What is the ratio of the Electricity production(% of total) of OECD members in 1998 to that in 1999?
Provide a succinct answer. 1.02. What is the ratio of the Electricity production(% of total) of Kazakhstan in 1998 to that in 1999?
Provide a short and direct response. 0.97. What is the ratio of the Electricity production(% of total) in Tajikistan in 1998 to that in 1999?
Give a very brief answer. 1. What is the ratio of the Electricity production(% of total) of Europe(developing only) in 1998 to that in 2000?
Offer a very short reply. 1.16. What is the ratio of the Electricity production(% of total) of OECD members in 1998 to that in 2000?
Provide a succinct answer. 1.05. What is the ratio of the Electricity production(% of total) of Kazakhstan in 1998 to that in 2000?
Make the answer very short. 0.85. What is the ratio of the Electricity production(% of total) in Europe(developing only) in 1998 to that in 2001?
Make the answer very short. 1.27. What is the ratio of the Electricity production(% of total) in OECD members in 1998 to that in 2001?
Your answer should be compact. 1.12. What is the ratio of the Electricity production(% of total) in Kazakhstan in 1998 to that in 2001?
Your answer should be compact. 0.88. What is the ratio of the Electricity production(% of total) of Tajikistan in 1998 to that in 2001?
Offer a terse response. 0.99. What is the ratio of the Electricity production(% of total) of Europe(developing only) in 1999 to that in 2000?
Make the answer very short. 1.13. What is the ratio of the Electricity production(% of total) in OECD members in 1999 to that in 2000?
Ensure brevity in your answer.  1.02. What is the ratio of the Electricity production(% of total) of Kazakhstan in 1999 to that in 2000?
Your answer should be compact. 0.88. What is the ratio of the Electricity production(% of total) of Europe(developing only) in 1999 to that in 2001?
Keep it short and to the point. 1.23. What is the ratio of the Electricity production(% of total) of OECD members in 1999 to that in 2001?
Provide a short and direct response. 1.09. What is the ratio of the Electricity production(% of total) of Kazakhstan in 1999 to that in 2001?
Your response must be concise. 0.91. What is the ratio of the Electricity production(% of total) in Tajikistan in 1999 to that in 2001?
Your response must be concise. 0.99. What is the ratio of the Electricity production(% of total) of Europe(developing only) in 2000 to that in 2001?
Your answer should be compact. 1.09. What is the ratio of the Electricity production(% of total) in OECD members in 2000 to that in 2001?
Ensure brevity in your answer.  1.07. What is the ratio of the Electricity production(% of total) in Kazakhstan in 2000 to that in 2001?
Offer a terse response. 1.03. What is the difference between the highest and the second highest Electricity production(% of total) in Europe(developing only)?
Provide a short and direct response. 0.67. What is the difference between the highest and the second highest Electricity production(% of total) of OECD members?
Provide a succinct answer. 0.03. What is the difference between the highest and the second highest Electricity production(% of total) in Kazakhstan?
Your answer should be very brief. 0.46. What is the difference between the highest and the second highest Electricity production(% of total) of Tajikistan?
Make the answer very short. 0.32. What is the difference between the highest and the lowest Electricity production(% of total) in Europe(developing only)?
Offer a terse response. 4.95. What is the difference between the highest and the lowest Electricity production(% of total) of OECD members?
Offer a terse response. 2.58. What is the difference between the highest and the lowest Electricity production(% of total) of Kazakhstan?
Offer a very short reply. 2.26. What is the difference between the highest and the lowest Electricity production(% of total) in Tajikistan?
Provide a short and direct response. 1.12. 